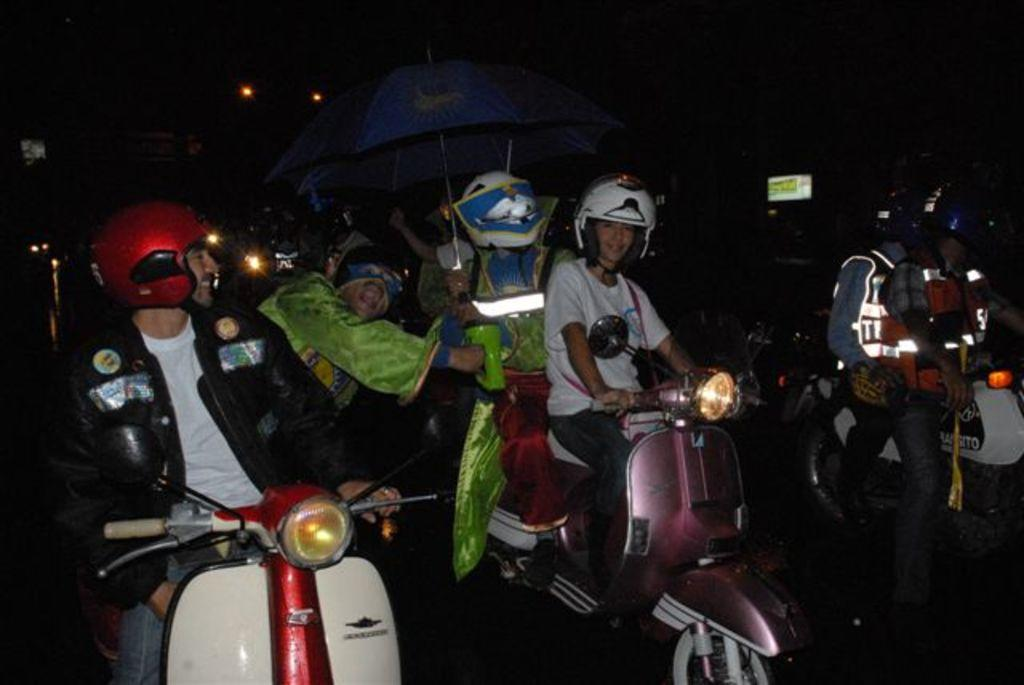What is the setting of the image? The image is set on a road. What mode of transportation can be seen in the image? There are people on a motorbike in the image. What feature of the motorbike is mentioned in the facts? The motorbike has lights on. What time of day is it in the image? It is night time in the image. What weather condition is present in the image? It is raining in the image. How many fingers can be seen making a statement in the image? There are no fingers or statements being made in the image. 